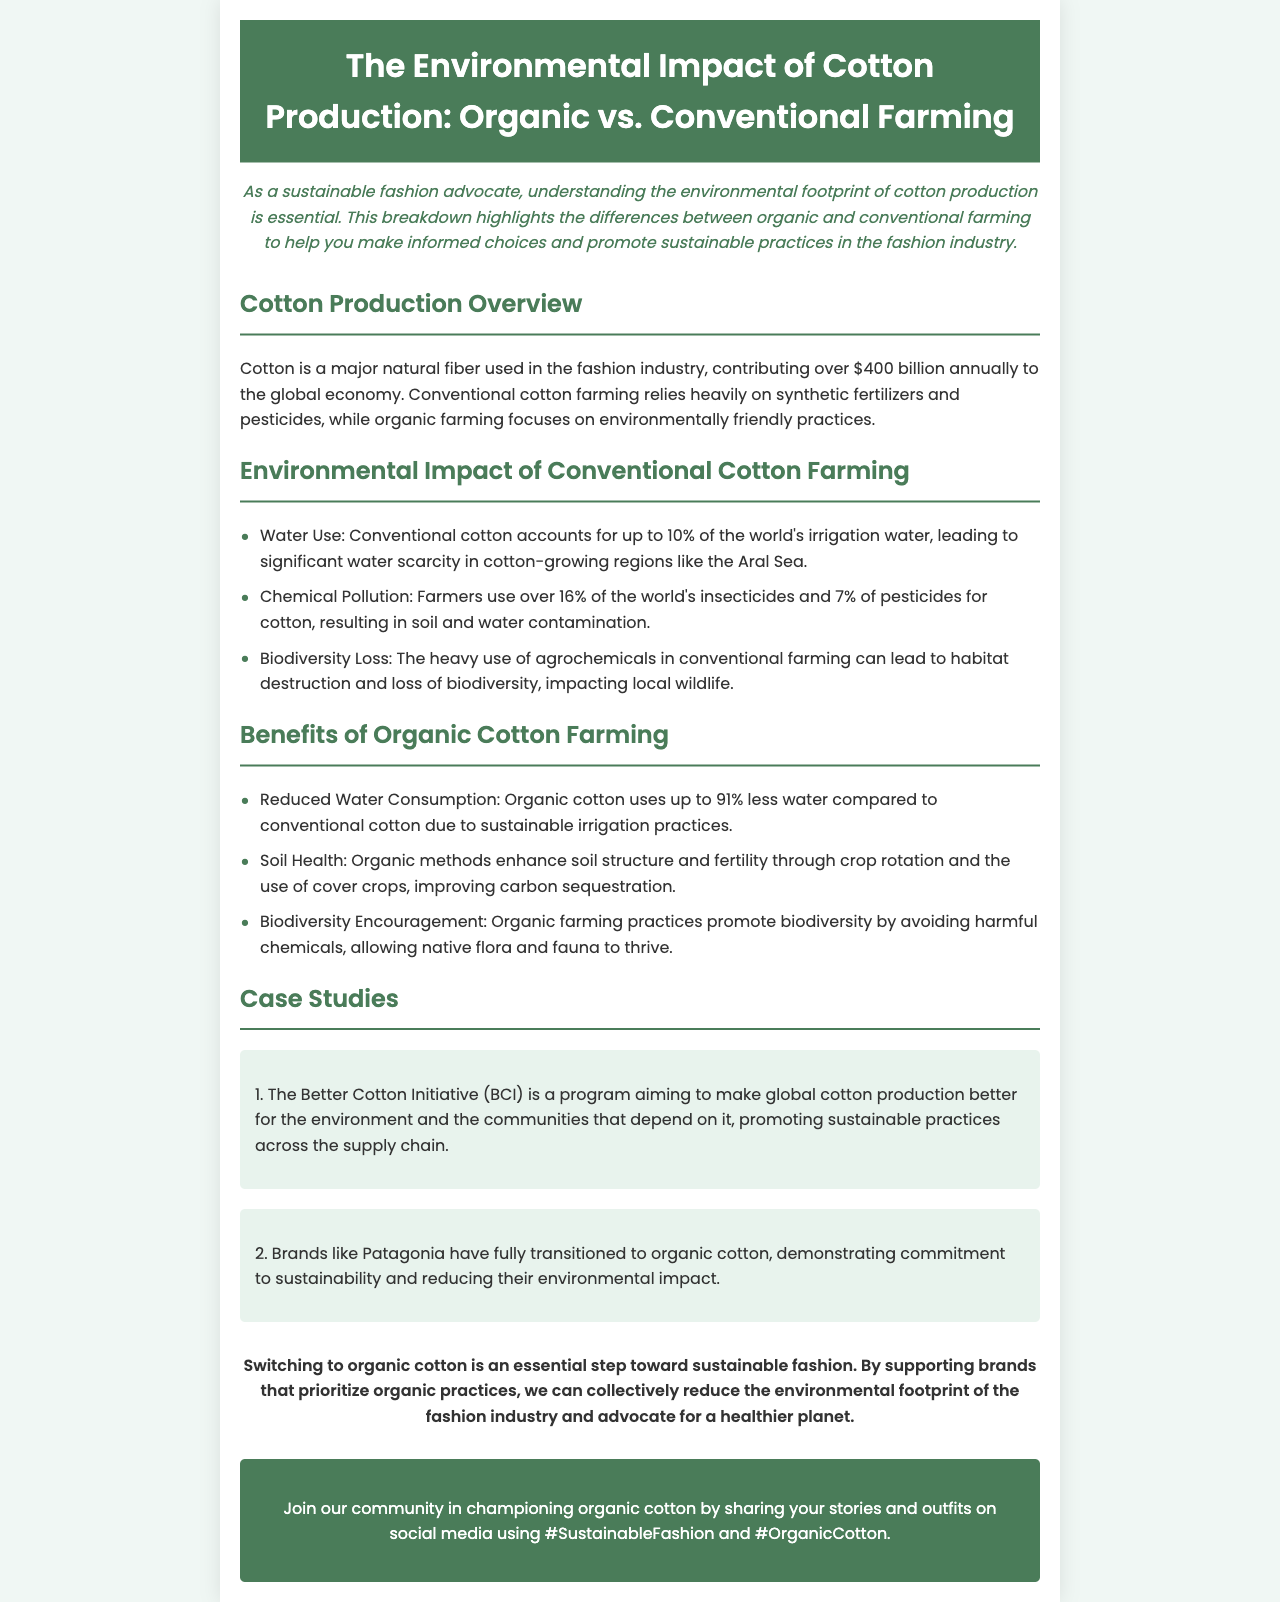What percentage of the world's irrigation water is used by conventional cotton? The document states that conventional cotton accounts for up to 10% of the world's irrigation water.
Answer: 10% What is one major chemical pollutant mentioned for conventional cotton farming? The document mentions over 16% of the world's insecticides as a chemical pollutant used in conventional cotton farming.
Answer: Insecticides How much less water does organic cotton use compared to conventional cotton? The document highlights that organic cotton uses up to 91% less water compared to conventional cotton.
Answer: 91% What does the Better Cotton Initiative (BCI) aim to improve? The document explains that BCI aims to make global cotton production better for the environment and communities.
Answer: Global cotton production Which brand has fully transitioned to organic cotton according to the case studies? The document states that Patagonia has fully transitioned to organic cotton.
Answer: Patagonia What aspect of farming does organic farming enhance through crop rotation? The document mentions that organic methods enhance soil structure and fertility.
Answer: Soil health What is a key consequence of chemical pollution from conventional cotton farming? The document indicates that chemical pollution leads to soil and water contamination.
Answer: Soil and water contamination Which phrase encourages readers to engage with the community on social media? The conclusion urges readers to share their stories using hashtags.
Answer: #SustainableFashion and #OrganicCotton 